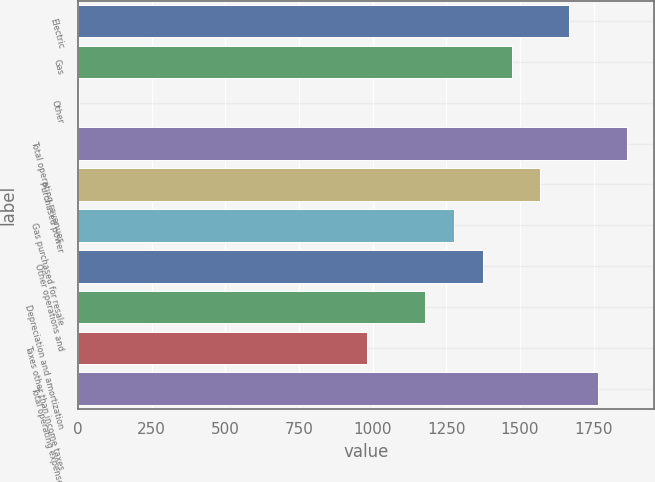<chart> <loc_0><loc_0><loc_500><loc_500><bar_chart><fcel>Electric<fcel>Gas<fcel>Other<fcel>Total operating revenues<fcel>Purchased power<fcel>Gas purchased for resale<fcel>Other operations and<fcel>Depreciation and amortization<fcel>Taxes other than income taxes<fcel>Total operating expenses<nl><fcel>1667.3<fcel>1471.5<fcel>3<fcel>1863.1<fcel>1569.4<fcel>1275.7<fcel>1373.6<fcel>1177.8<fcel>982<fcel>1765.2<nl></chart> 